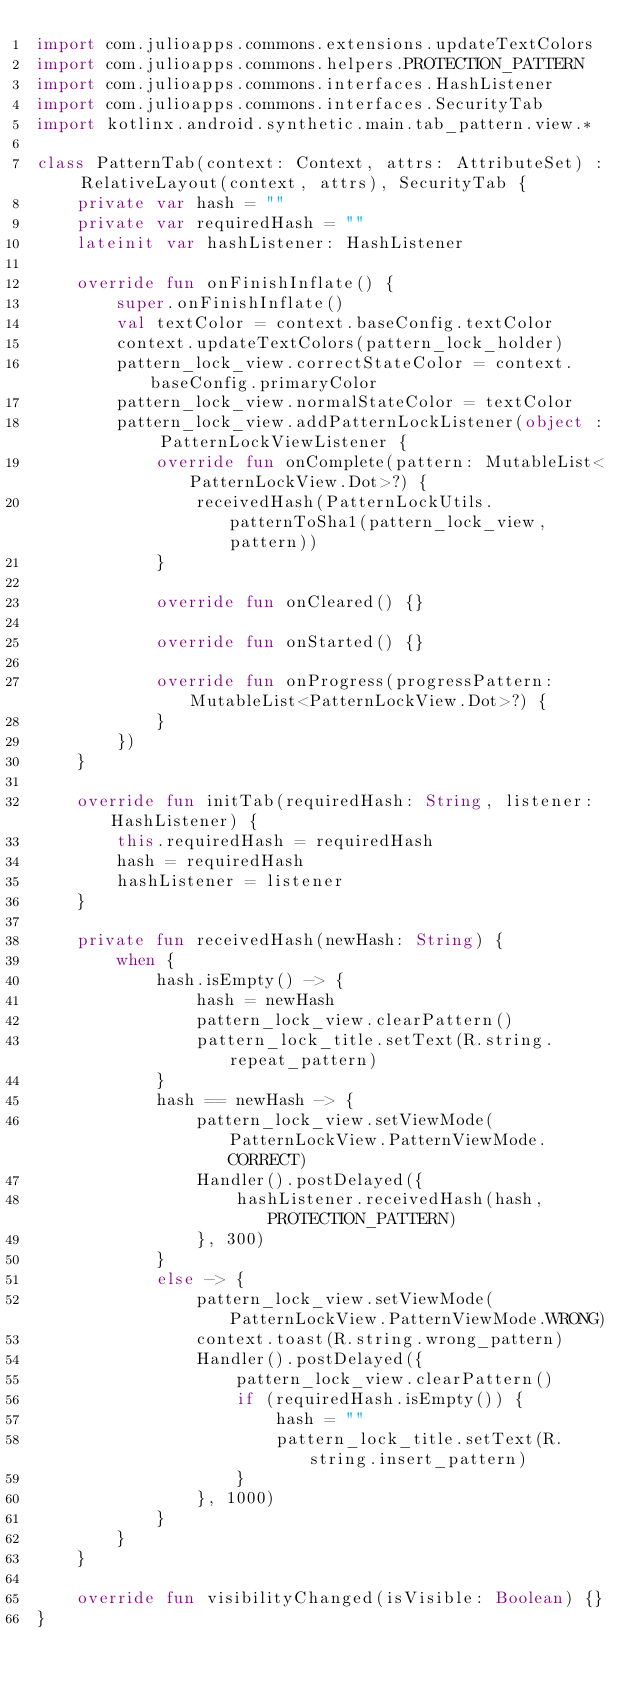Convert code to text. <code><loc_0><loc_0><loc_500><loc_500><_Kotlin_>import com.julioapps.commons.extensions.updateTextColors
import com.julioapps.commons.helpers.PROTECTION_PATTERN
import com.julioapps.commons.interfaces.HashListener
import com.julioapps.commons.interfaces.SecurityTab
import kotlinx.android.synthetic.main.tab_pattern.view.*

class PatternTab(context: Context, attrs: AttributeSet) : RelativeLayout(context, attrs), SecurityTab {
    private var hash = ""
    private var requiredHash = ""
    lateinit var hashListener: HashListener

    override fun onFinishInflate() {
        super.onFinishInflate()
        val textColor = context.baseConfig.textColor
        context.updateTextColors(pattern_lock_holder)
        pattern_lock_view.correctStateColor = context.baseConfig.primaryColor
        pattern_lock_view.normalStateColor = textColor
        pattern_lock_view.addPatternLockListener(object : PatternLockViewListener {
            override fun onComplete(pattern: MutableList<PatternLockView.Dot>?) {
                receivedHash(PatternLockUtils.patternToSha1(pattern_lock_view, pattern))
            }

            override fun onCleared() {}

            override fun onStarted() {}

            override fun onProgress(progressPattern: MutableList<PatternLockView.Dot>?) {
            }
        })
    }

    override fun initTab(requiredHash: String, listener: HashListener) {
        this.requiredHash = requiredHash
        hash = requiredHash
        hashListener = listener
    }

    private fun receivedHash(newHash: String) {
        when {
            hash.isEmpty() -> {
                hash = newHash
                pattern_lock_view.clearPattern()
                pattern_lock_title.setText(R.string.repeat_pattern)
            }
            hash == newHash -> {
                pattern_lock_view.setViewMode(PatternLockView.PatternViewMode.CORRECT)
                Handler().postDelayed({
                    hashListener.receivedHash(hash, PROTECTION_PATTERN)
                }, 300)
            }
            else -> {
                pattern_lock_view.setViewMode(PatternLockView.PatternViewMode.WRONG)
                context.toast(R.string.wrong_pattern)
                Handler().postDelayed({
                    pattern_lock_view.clearPattern()
                    if (requiredHash.isEmpty()) {
                        hash = ""
                        pattern_lock_title.setText(R.string.insert_pattern)
                    }
                }, 1000)
            }
        }
    }

    override fun visibilityChanged(isVisible: Boolean) {}
}
</code> 